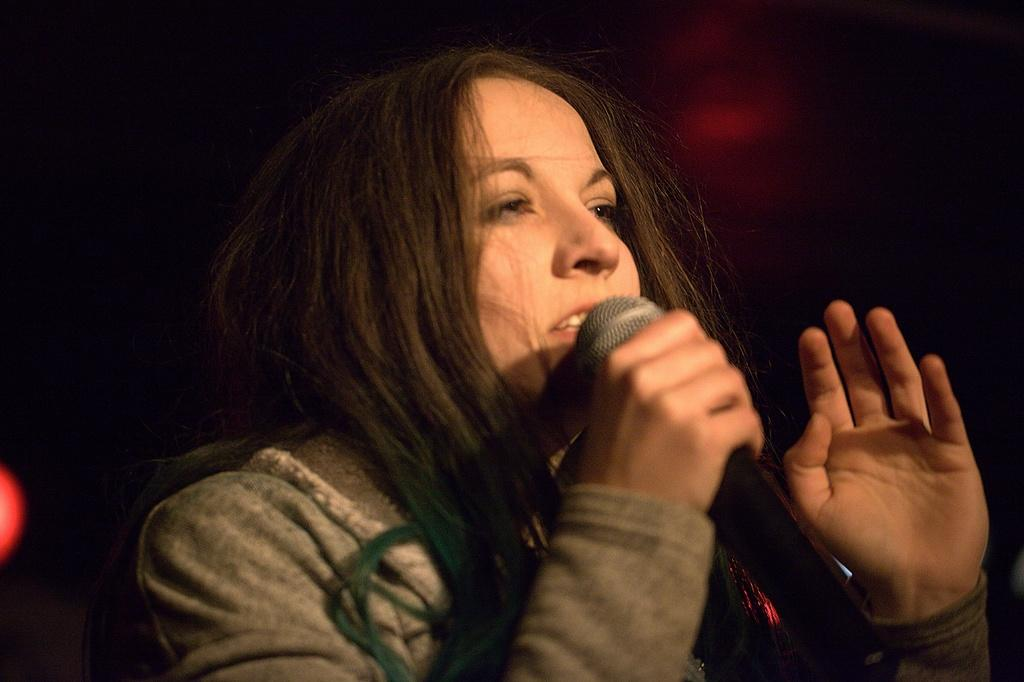Who is the main subject in the image? There is a woman in the image. What is the woman wearing? The woman is wearing a grey jacket. What is the woman holding in the image? The woman is holding a microphone. What is the woman doing with the microphone? The woman is talking into the microphone. Can you see a cat in the image? No, there is no cat present in the image. Does the existence of the woman in the image prove the existence of extraterrestrial life? No, the existence of the woman in the image does not prove the existence of extraterrestrial life. 